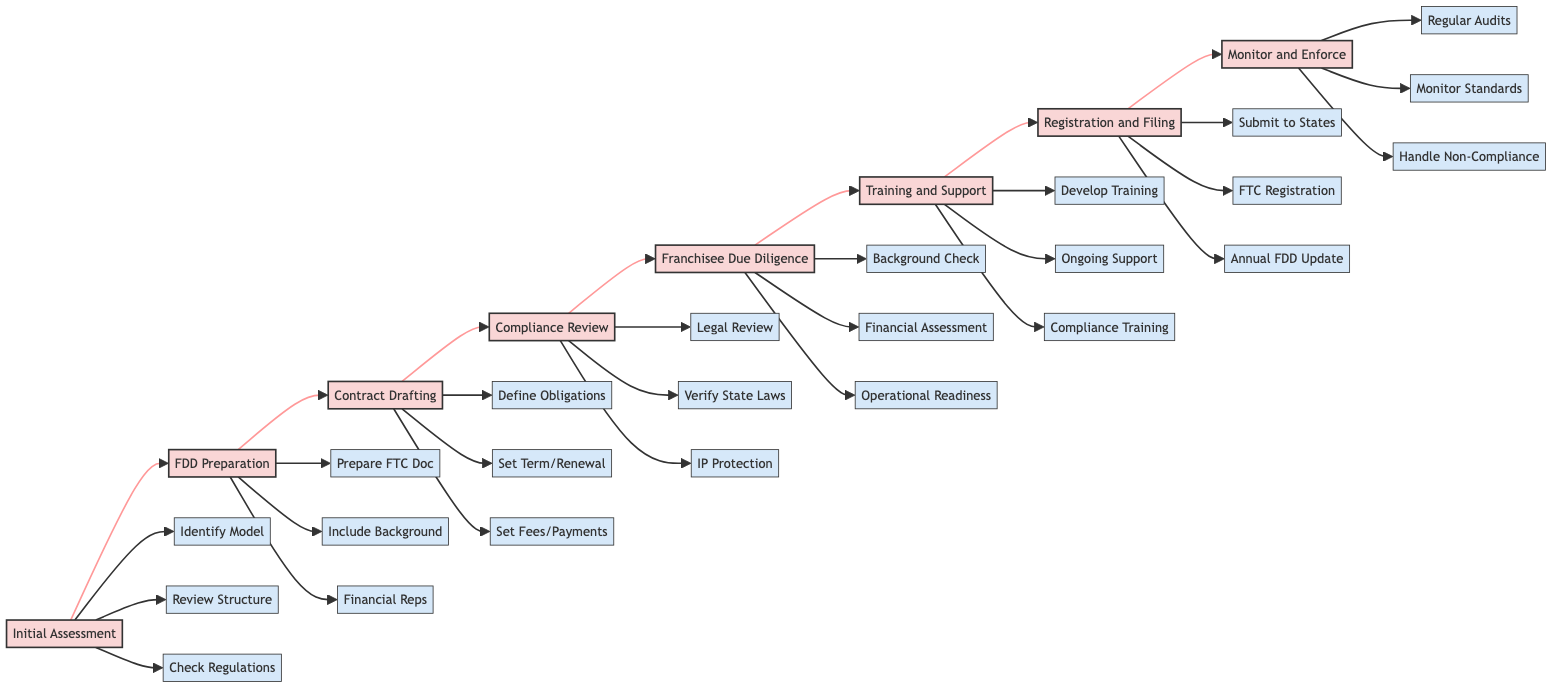What is the first step in the compliance checklist? The diagram starts with the "Initial Assessment" as the first step in the horizontal flowchart.
Answer: Initial Assessment How many tasks are involved in the "Contract Drafting" step? The "Contract Drafting" step has three associated tasks: defining obligations, setting term and renewal, and setting fees and payments.
Answer: 3 Which step follows "Franchisee Due Diligence"? The diagram shows that the "Training and Support" step comes directly after "Franchisee Due Diligence."
Answer: Training and Support What is the last step in the flowchart? The last step in the horizontal flowchart is "Monitor and Enforce Compliance."
Answer: Monitor and Enforce List the tasks associated with "Compliance Review". The diagram identifies three tasks under "Compliance Review": legal review of the franchise agreement, verifying compliance with state laws, and addressing intellectual property protection.
Answer: Legal review, Verify compliance with state laws, Address IP protection Explain the relationship between "Initial Assessment" and "FDD Preparation". "FDD Preparation" directly follows "Initial Assessment" in the flowchart, indicating that the tasks in "Initial Assessment" must be completed before moving on to "FDD Preparation".
Answer: Sequential relationship How many total steps are depicted in the diagram? The diagram displays a total of eight steps, including the initial assessment and monitoring compliance.
Answer: 8 Which task in "Registration and Filing" is related to annual updates? The task "Update Franchise Disclosure Document Annually" found within the "Registration and Filing" step addresses the annual updates.
Answer: Update Franchise Disclosure Document Annually What kind of reviews take place in the "Compliance Review" step? The "Compliance Review" step involves legal reviews and verification of compliance with state laws, along with addressing intellectual property protection.
Answer: Legal reviews, Verification of state laws, IP protection Which step requires a financial stability assessment? The "Franchisee Due Diligence" step includes the task of conducting a financial stability assessment.
Answer: Franchisee Due Diligence 